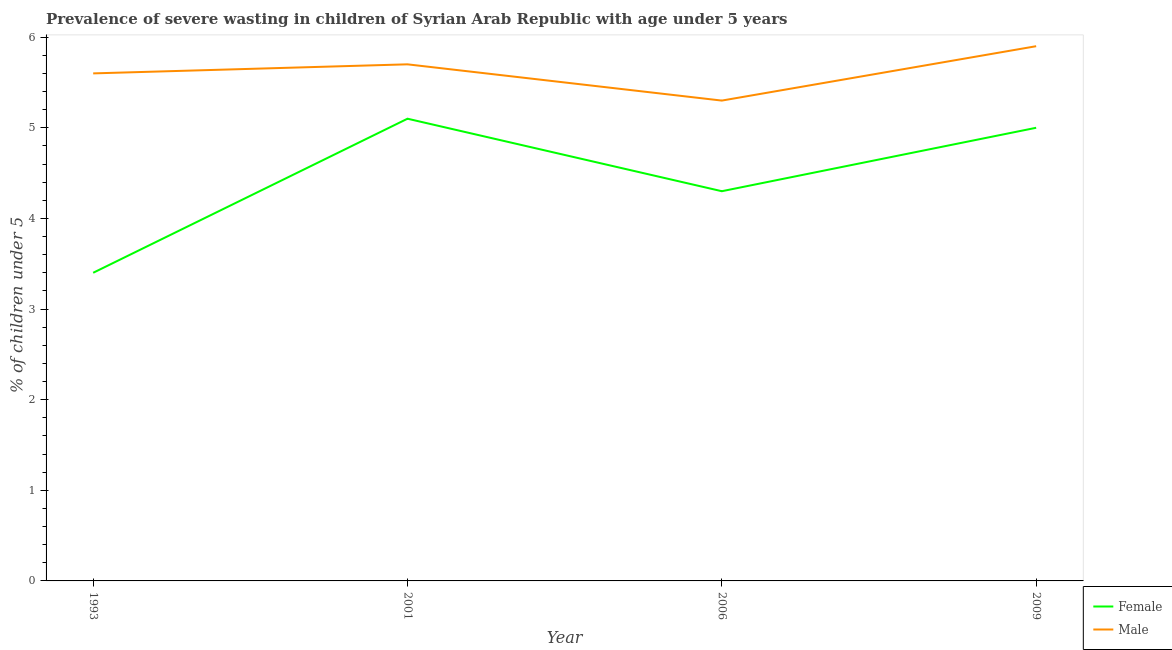How many different coloured lines are there?
Your answer should be very brief. 2. Is the number of lines equal to the number of legend labels?
Offer a terse response. Yes. What is the percentage of undernourished female children in 2001?
Provide a succinct answer. 5.1. Across all years, what is the maximum percentage of undernourished female children?
Give a very brief answer. 5.1. Across all years, what is the minimum percentage of undernourished female children?
Your answer should be compact. 3.4. In which year was the percentage of undernourished female children maximum?
Offer a very short reply. 2001. In which year was the percentage of undernourished male children minimum?
Keep it short and to the point. 2006. What is the total percentage of undernourished male children in the graph?
Your response must be concise. 22.5. What is the difference between the percentage of undernourished male children in 1993 and that in 2006?
Your answer should be very brief. 0.3. What is the difference between the percentage of undernourished female children in 2009 and the percentage of undernourished male children in 2006?
Your response must be concise. -0.3. What is the average percentage of undernourished male children per year?
Keep it short and to the point. 5.62. In the year 2006, what is the difference between the percentage of undernourished female children and percentage of undernourished male children?
Make the answer very short. -1. What is the ratio of the percentage of undernourished female children in 1993 to that in 2006?
Keep it short and to the point. 0.79. Is the percentage of undernourished male children in 1993 less than that in 2009?
Provide a succinct answer. Yes. What is the difference between the highest and the second highest percentage of undernourished female children?
Make the answer very short. 0.1. What is the difference between the highest and the lowest percentage of undernourished female children?
Provide a succinct answer. 1.7. Is the sum of the percentage of undernourished female children in 2001 and 2009 greater than the maximum percentage of undernourished male children across all years?
Provide a succinct answer. Yes. Is the percentage of undernourished female children strictly greater than the percentage of undernourished male children over the years?
Ensure brevity in your answer.  No. Is the percentage of undernourished male children strictly less than the percentage of undernourished female children over the years?
Ensure brevity in your answer.  No. How many years are there in the graph?
Offer a very short reply. 4. What is the difference between two consecutive major ticks on the Y-axis?
Offer a terse response. 1. Does the graph contain any zero values?
Make the answer very short. No. Does the graph contain grids?
Provide a short and direct response. No. How many legend labels are there?
Provide a succinct answer. 2. What is the title of the graph?
Your answer should be very brief. Prevalence of severe wasting in children of Syrian Arab Republic with age under 5 years. What is the label or title of the Y-axis?
Give a very brief answer.  % of children under 5. What is the  % of children under 5 of Female in 1993?
Your answer should be compact. 3.4. What is the  % of children under 5 of Male in 1993?
Give a very brief answer. 5.6. What is the  % of children under 5 in Female in 2001?
Give a very brief answer. 5.1. What is the  % of children under 5 of Male in 2001?
Your response must be concise. 5.7. What is the  % of children under 5 of Female in 2006?
Give a very brief answer. 4.3. What is the  % of children under 5 in Male in 2006?
Make the answer very short. 5.3. What is the  % of children under 5 of Female in 2009?
Keep it short and to the point. 5. What is the  % of children under 5 in Male in 2009?
Offer a very short reply. 5.9. Across all years, what is the maximum  % of children under 5 in Female?
Your response must be concise. 5.1. Across all years, what is the maximum  % of children under 5 of Male?
Your answer should be compact. 5.9. Across all years, what is the minimum  % of children under 5 of Female?
Make the answer very short. 3.4. Across all years, what is the minimum  % of children under 5 of Male?
Offer a terse response. 5.3. What is the total  % of children under 5 of Male in the graph?
Your answer should be compact. 22.5. What is the difference between the  % of children under 5 in Male in 1993 and that in 2001?
Give a very brief answer. -0.1. What is the difference between the  % of children under 5 of Female in 1993 and that in 2006?
Offer a terse response. -0.9. What is the difference between the  % of children under 5 in Male in 1993 and that in 2006?
Your response must be concise. 0.3. What is the difference between the  % of children under 5 of Female in 1993 and that in 2009?
Offer a very short reply. -1.6. What is the difference between the  % of children under 5 of Female in 2001 and that in 2006?
Keep it short and to the point. 0.8. What is the difference between the  % of children under 5 in Male in 2001 and that in 2006?
Your answer should be compact. 0.4. What is the difference between the  % of children under 5 of Female in 2001 and that in 2009?
Provide a succinct answer. 0.1. What is the difference between the  % of children under 5 in Male in 2001 and that in 2009?
Keep it short and to the point. -0.2. What is the difference between the  % of children under 5 in Female in 2006 and that in 2009?
Your answer should be compact. -0.7. What is the difference between the  % of children under 5 of Male in 2006 and that in 2009?
Your answer should be very brief. -0.6. What is the difference between the  % of children under 5 in Female in 1993 and the  % of children under 5 in Male in 2001?
Your response must be concise. -2.3. What is the difference between the  % of children under 5 in Female in 1993 and the  % of children under 5 in Male in 2009?
Offer a very short reply. -2.5. What is the difference between the  % of children under 5 of Female in 2001 and the  % of children under 5 of Male in 2009?
Your response must be concise. -0.8. What is the average  % of children under 5 of Female per year?
Your response must be concise. 4.45. What is the average  % of children under 5 in Male per year?
Make the answer very short. 5.62. In the year 1993, what is the difference between the  % of children under 5 of Female and  % of children under 5 of Male?
Your answer should be compact. -2.2. In the year 2001, what is the difference between the  % of children under 5 in Female and  % of children under 5 in Male?
Keep it short and to the point. -0.6. What is the ratio of the  % of children under 5 of Male in 1993 to that in 2001?
Your response must be concise. 0.98. What is the ratio of the  % of children under 5 in Female in 1993 to that in 2006?
Your answer should be compact. 0.79. What is the ratio of the  % of children under 5 of Male in 1993 to that in 2006?
Your answer should be compact. 1.06. What is the ratio of the  % of children under 5 in Female in 1993 to that in 2009?
Provide a succinct answer. 0.68. What is the ratio of the  % of children under 5 in Male in 1993 to that in 2009?
Provide a succinct answer. 0.95. What is the ratio of the  % of children under 5 of Female in 2001 to that in 2006?
Make the answer very short. 1.19. What is the ratio of the  % of children under 5 in Male in 2001 to that in 2006?
Ensure brevity in your answer.  1.08. What is the ratio of the  % of children under 5 of Male in 2001 to that in 2009?
Give a very brief answer. 0.97. What is the ratio of the  % of children under 5 in Female in 2006 to that in 2009?
Provide a short and direct response. 0.86. What is the ratio of the  % of children under 5 in Male in 2006 to that in 2009?
Your response must be concise. 0.9. What is the difference between the highest and the second highest  % of children under 5 in Female?
Make the answer very short. 0.1. What is the difference between the highest and the second highest  % of children under 5 of Male?
Your answer should be compact. 0.2. What is the difference between the highest and the lowest  % of children under 5 of Female?
Provide a succinct answer. 1.7. 